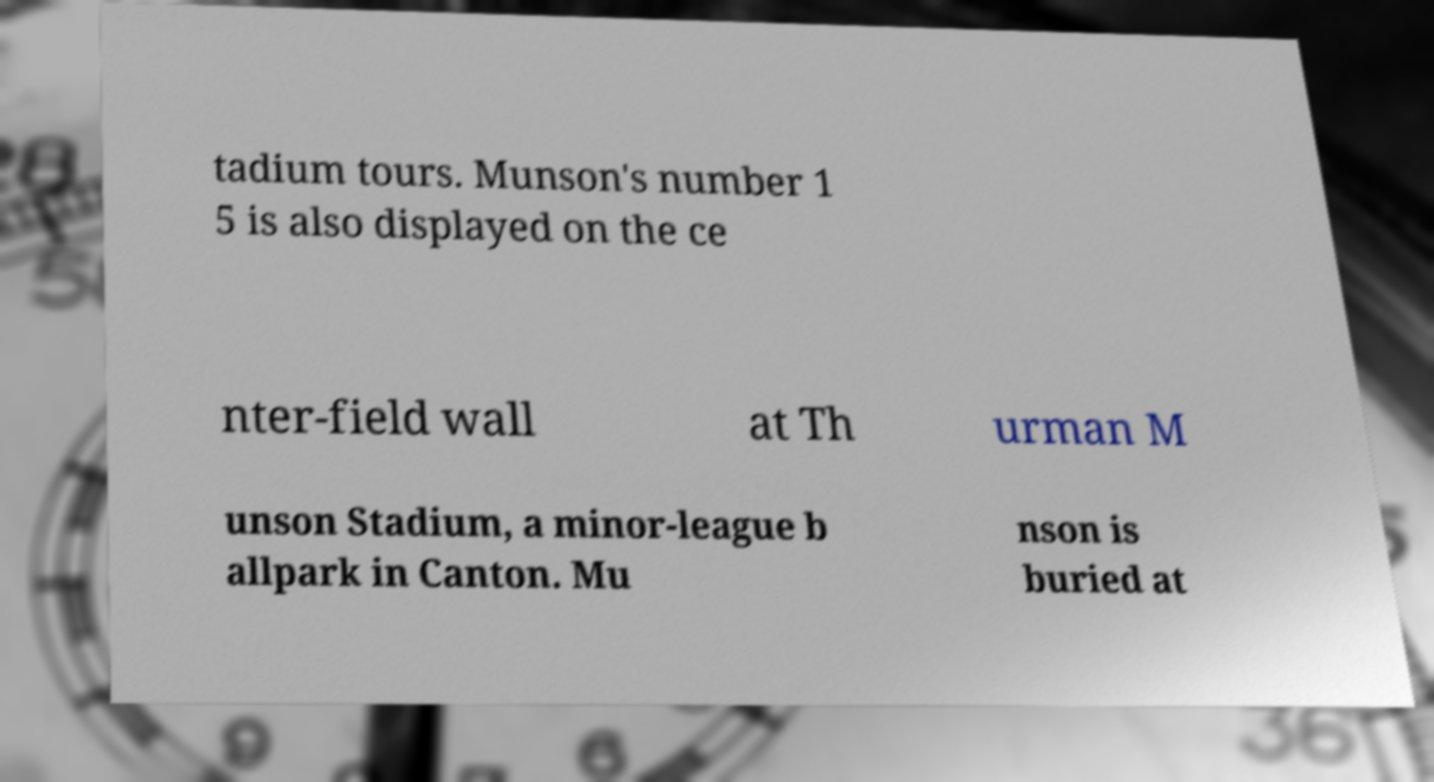There's text embedded in this image that I need extracted. Can you transcribe it verbatim? tadium tours. Munson's number 1 5 is also displayed on the ce nter-field wall at Th urman M unson Stadium, a minor-league b allpark in Canton. Mu nson is buried at 